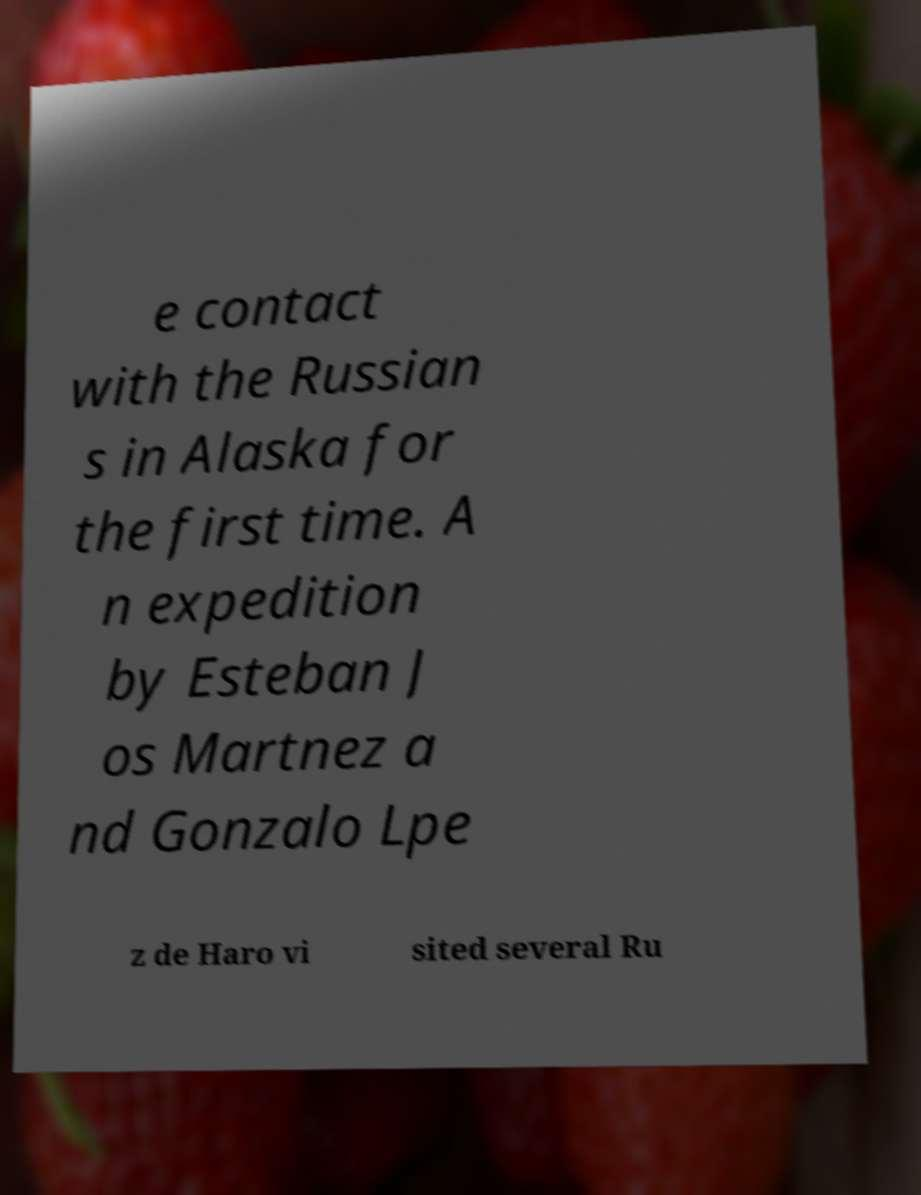Please read and relay the text visible in this image. What does it say? e contact with the Russian s in Alaska for the first time. A n expedition by Esteban J os Martnez a nd Gonzalo Lpe z de Haro vi sited several Ru 